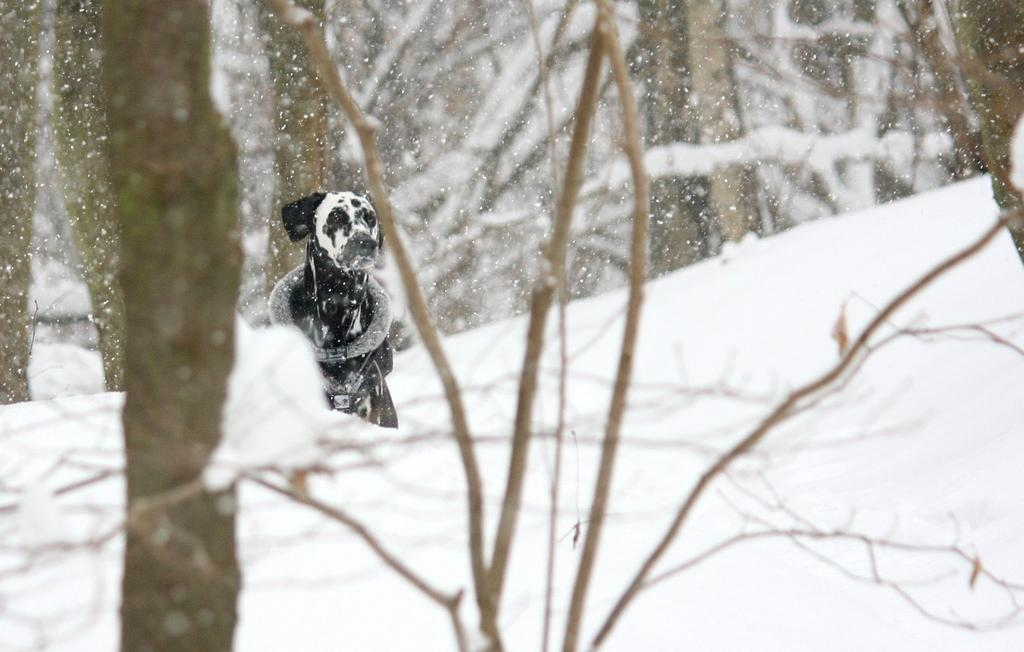What animal can be seen in the image? There is a dog in the image. Where is the dog located? The dog is in the snow. What is happening in the background of the image? Snow is falling in the image. What can be seen in the blurred surroundings of the image? Trees are visible in the blurred surroundings. What type of jam is the boy eating in the image? There is no boy or jam present in the image; it features a dog in the snow with falling snow and blurred surroundings. 